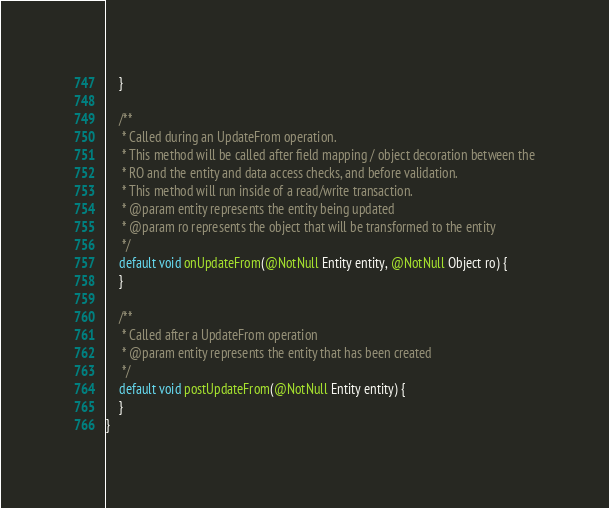<code> <loc_0><loc_0><loc_500><loc_500><_Java_>	}

	/**
	 * Called during an UpdateFrom operation.
	 * This method will be called after field mapping / object decoration between the
	 * RO and the entity and data access checks, and before validation.
	 * This method will run inside of a read/write transaction.
	 * @param entity represents the entity being updated
	 * @param ro represents the object that will be transformed to the entity
	 */
	default void onUpdateFrom(@NotNull Entity entity, @NotNull Object ro) {
	}

	/**
	 * Called after a UpdateFrom operation
	 * @param entity represents the entity that has been created
	 */
	default void postUpdateFrom(@NotNull Entity entity) {
	}
}
</code> 